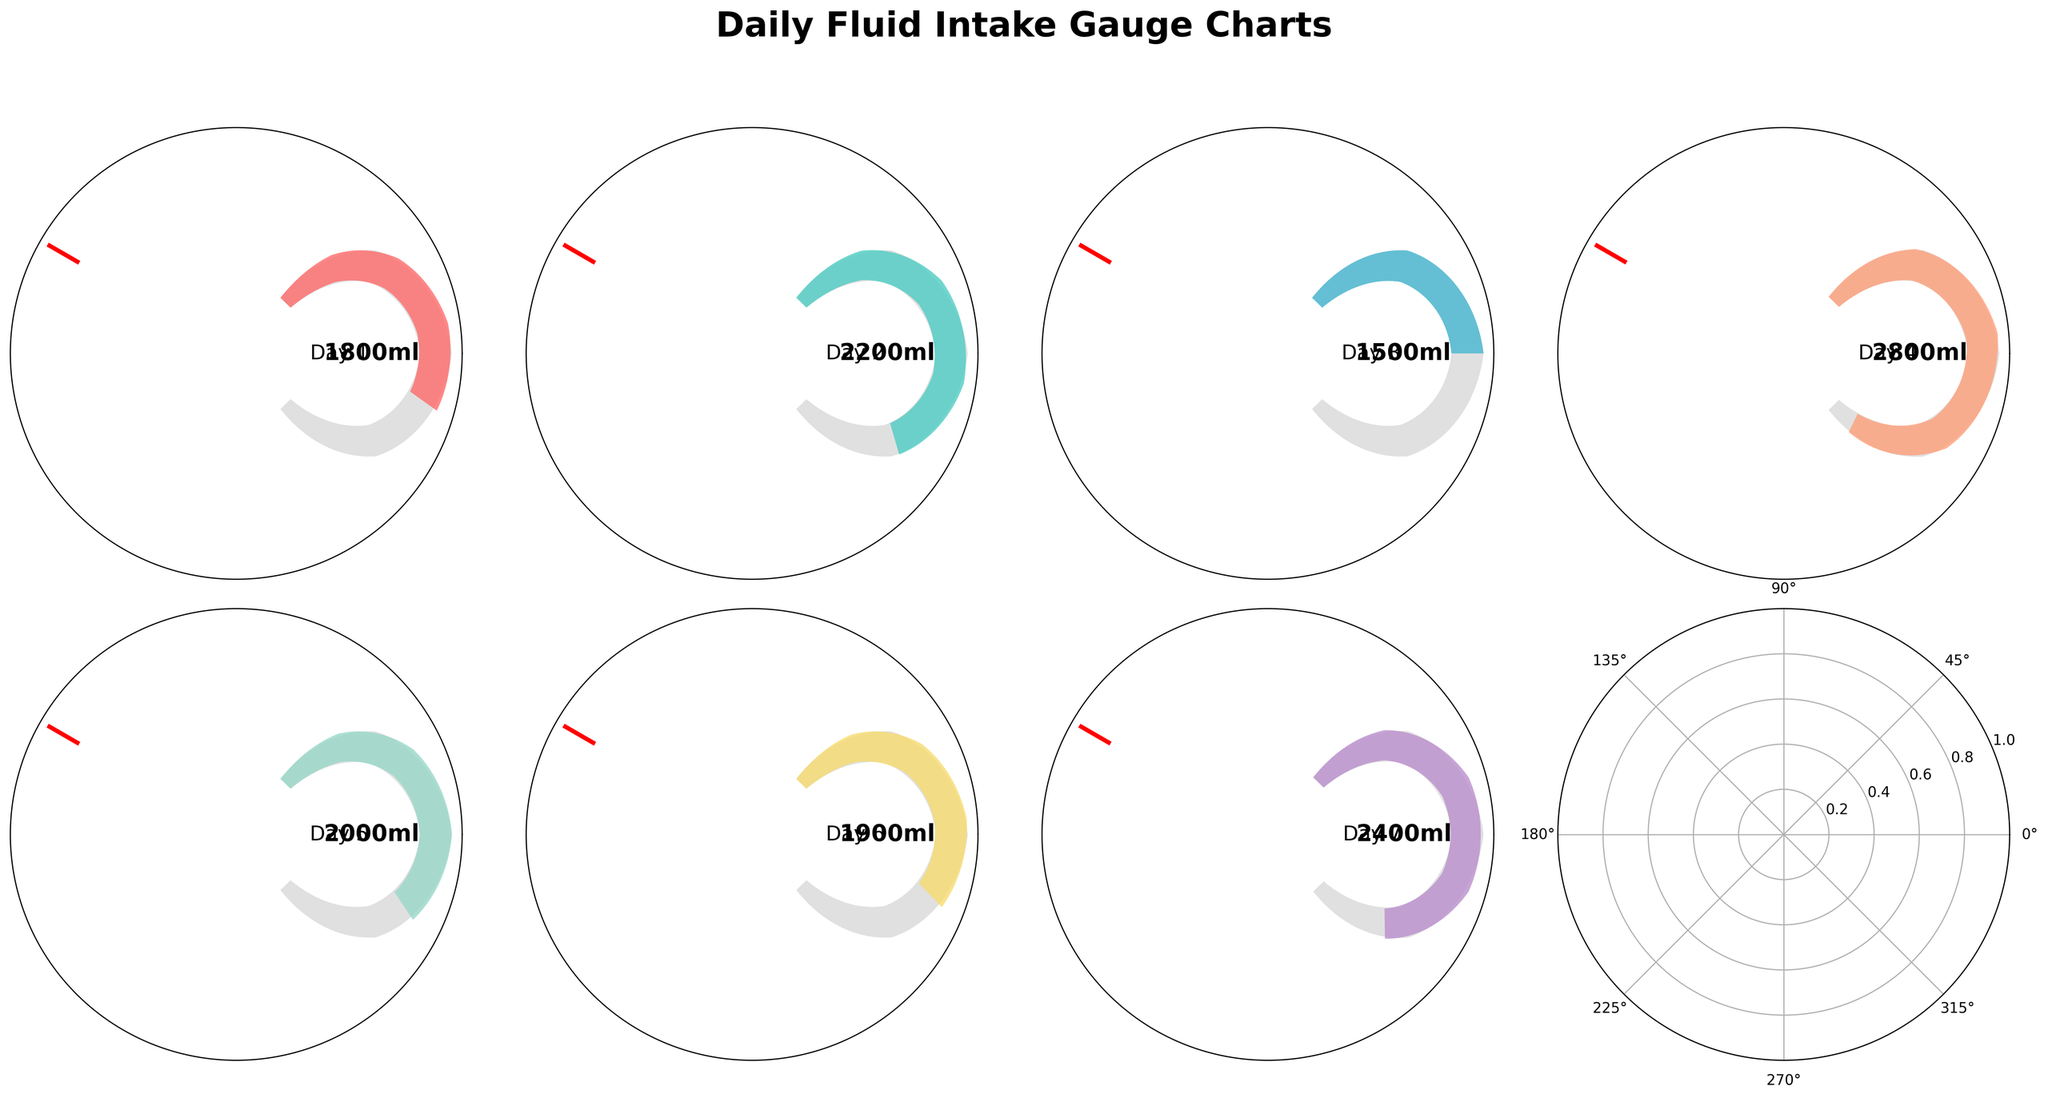How many days are covered by the gauge charts? The figure shows gauge charts for each day, which can be counted directly.
Answer: 7 What is the recommended daily fluid intake? The recommended daily fluid intake is depicted in the gauge charts by a red line.
Answer: 2500 ml For which day was the fluid intake the highest? Inspect the gauge charts and compare the fluid intake values provided for each day.
Answer: Day 4 What is the difference in fluid intake between the day with the highest and the lowest intake? Day 4 has the highest intake (2800 ml) and Day 3 has the lowest intake (1500 ml). The difference is 2800 ml - 1500 ml.
Answer: 1300 ml How many days did the fluid intake meet or exceed the recommended intake? Compare each day's intake with the recommended intake line (2500 ml). Count the days where the intake is equal to or exceeds 2500 ml.
Answer: 1 day On which day was the fluid intake closest to the recommended intake without exceeding it? Examine the gauge charts and identify the day where the intake is closest but less than 2500 ml.
Answer: Day 1 Which days have a fluid intake that falls below 2000 ml? Check each day's intake and note the days where the fluid intake is below 2000 ml.
Answer: Days 1, 3, 6 What is the average daily fluid intake over the week? Sum all the daily intakes and divide by the number of days. (1800+2200+1500+2800+2000+1900+2400)/7 = 2099 ml
Answer: 2099 ml Which day had the fluid intake closest to the maximum limit? The maximum limit is 3000 ml. Identify the day with the intake closest to 3000 ml without exceeding it.
Answer: Day 4 What is the range of daily fluid intakes over the week? The range is calculated as the difference between the maximum and minimum intakes. Day 4 (2800 ml) and Day 3 (1500 ml) provide the values. Range = 2800 ml - 1500 ml.
Answer: 1300 ml 